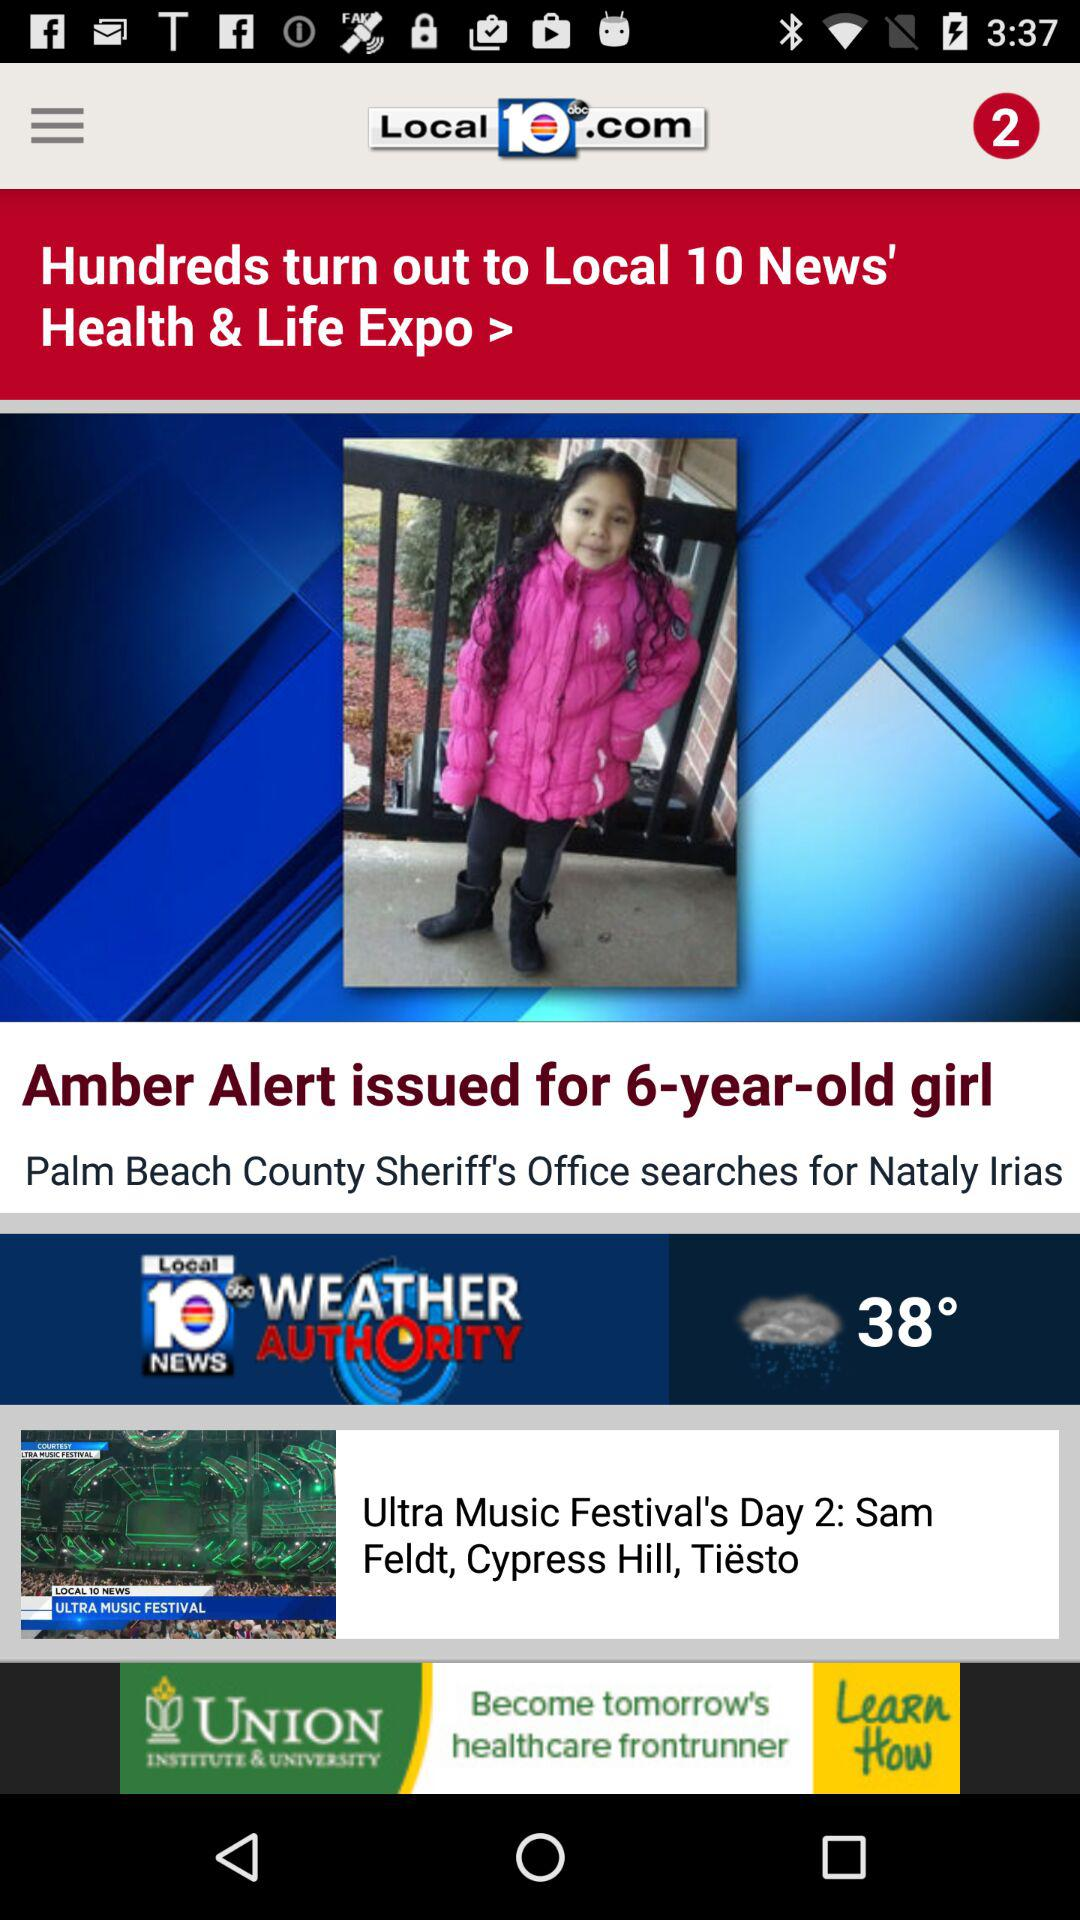What is the temperature? The temperature is 38°. 